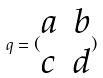<formula> <loc_0><loc_0><loc_500><loc_500>q = ( \begin{matrix} a & b \\ c & d \end{matrix} )</formula> 